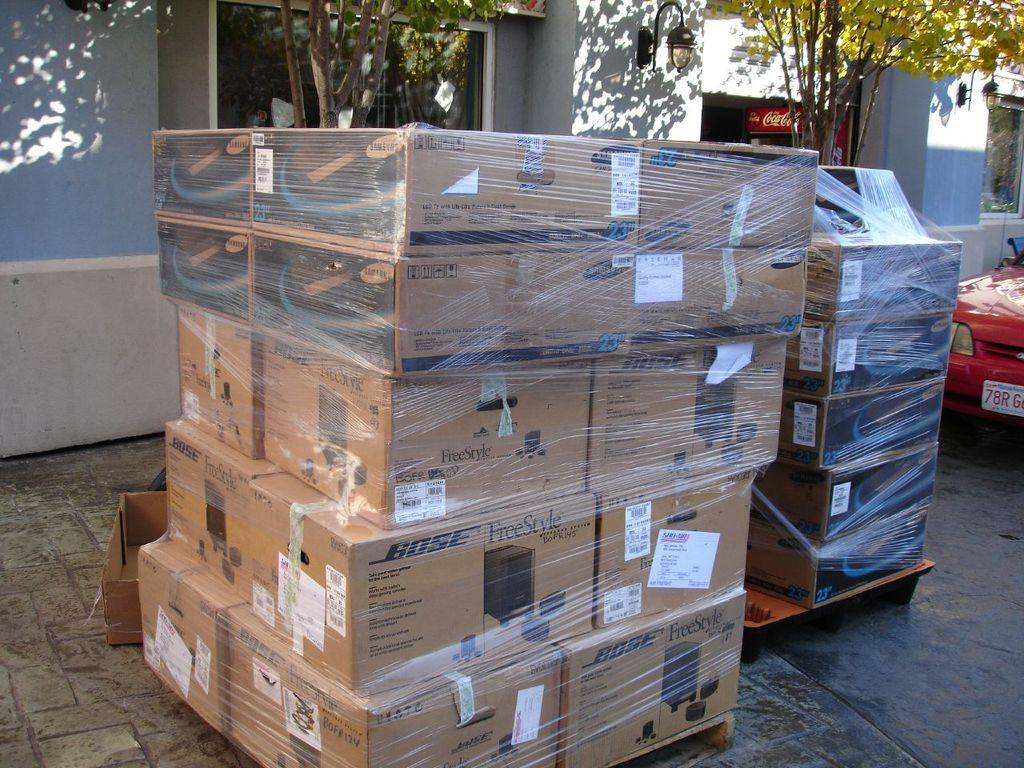<image>
Share a concise interpretation of the image provided. Bose and Samsung boxes are mixed together and wrapped up on a pallet. 